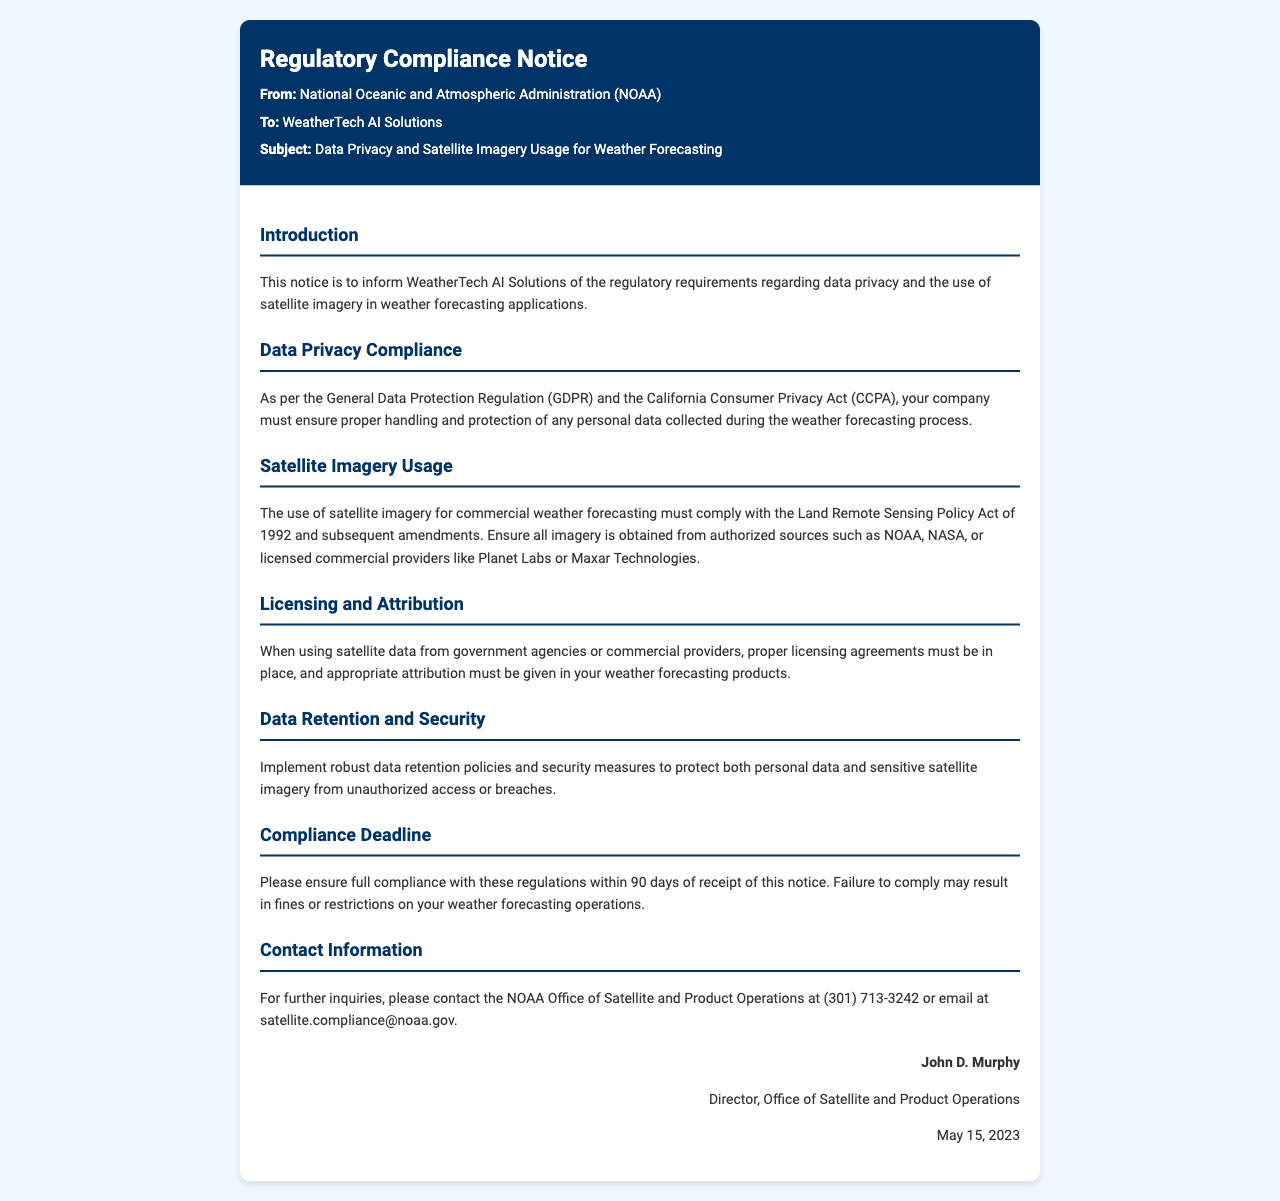what is the subject of the notice? The subject is mentioned in the header of the document, which indicates the main topic being addressed.
Answer: Data Privacy and Satellite Imagery Usage for Weather Forecasting who is the sender of the notice? The sender is specified in the header section of the document, indicating the organization that issued the compliance notice.
Answer: National Oceanic and Atmospheric Administration (NOAA) what regulation is cited concerning data privacy? The document specifically mentions regulations that are applicable for data privacy compliance.
Answer: General Data Protection Regulation (GDPR) what is the compliance deadline given in the notice? The document clearly states a timeline for compliance that is crucial for the recipient organization.
Answer: 90 days which act governs satellite imagery usage? The relevant act regarding satellite imagery is explicitly stated within the notice.
Answer: Land Remote Sensing Policy Act of 1992 what should be implemented to protect data and imagery? The notice discusses measures that should be adopted to ensure the security of data and imagery.
Answer: Robust data retention policies and security measures what is the contact email for inquiries? The document provides contact information, including an email address for any follow-up questions.
Answer: satellite.compliance@noaa.gov who signed the notice? The footer of the document includes the name of the person who issued the compliance notice.
Answer: John D. Murphy which company is the recipient of the notice? The recipient of the notice is mentioned directly in the header.
Answer: WeatherTech AI Solutions what may happen if compliance is not achieved? The notice warns about consequences of failing to comply with the stated regulations.
Answer: Fines or restrictions on your weather forecasting operations 